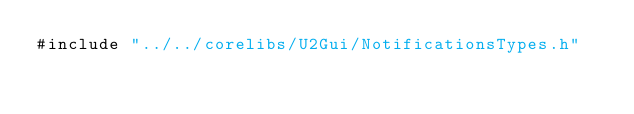Convert code to text. <code><loc_0><loc_0><loc_500><loc_500><_C_>#include "../../corelibs/U2Gui/NotificationsTypes.h"
</code> 